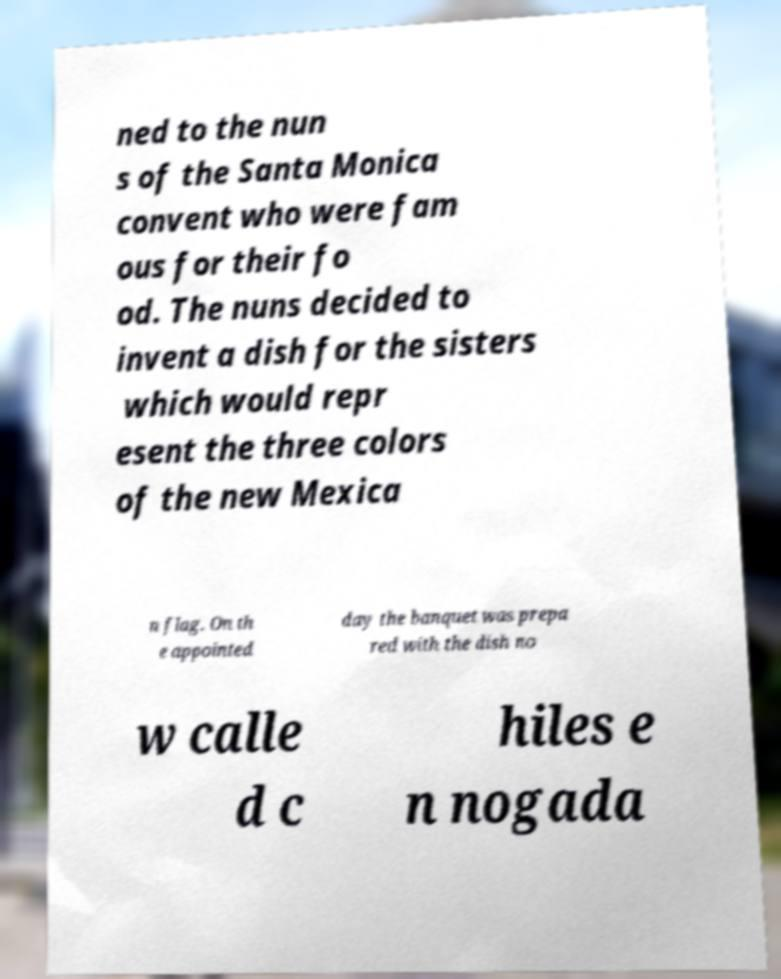I need the written content from this picture converted into text. Can you do that? ned to the nun s of the Santa Monica convent who were fam ous for their fo od. The nuns decided to invent a dish for the sisters which would repr esent the three colors of the new Mexica n flag. On th e appointed day the banquet was prepa red with the dish no w calle d c hiles e n nogada 